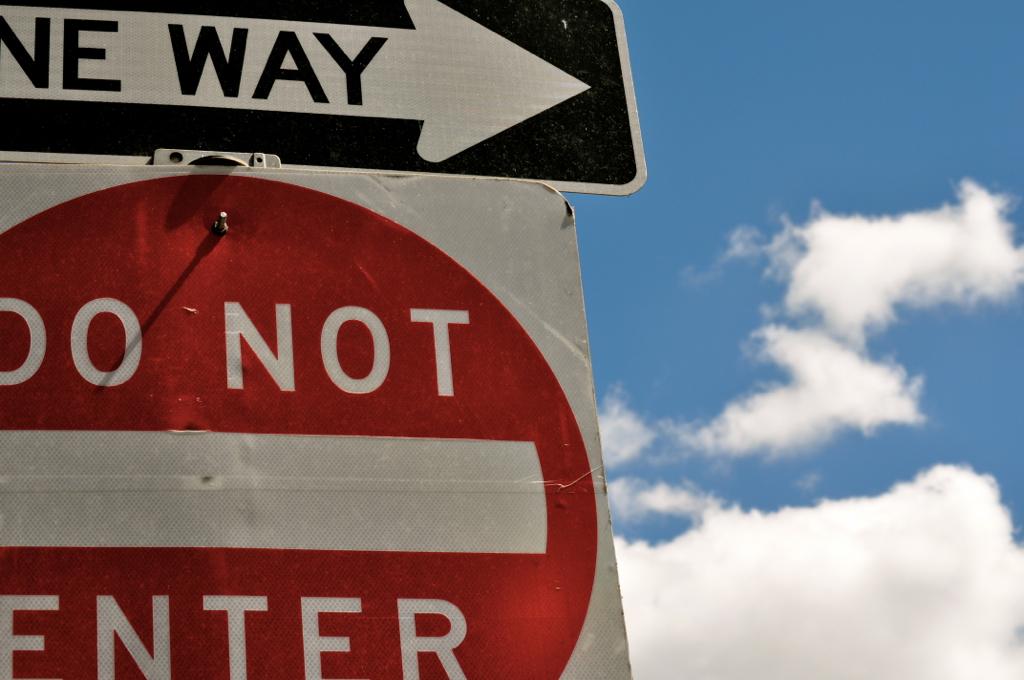What does the sign say?
Provide a succinct answer. Do not enter. What does the top sign say?
Provide a short and direct response. One way. 